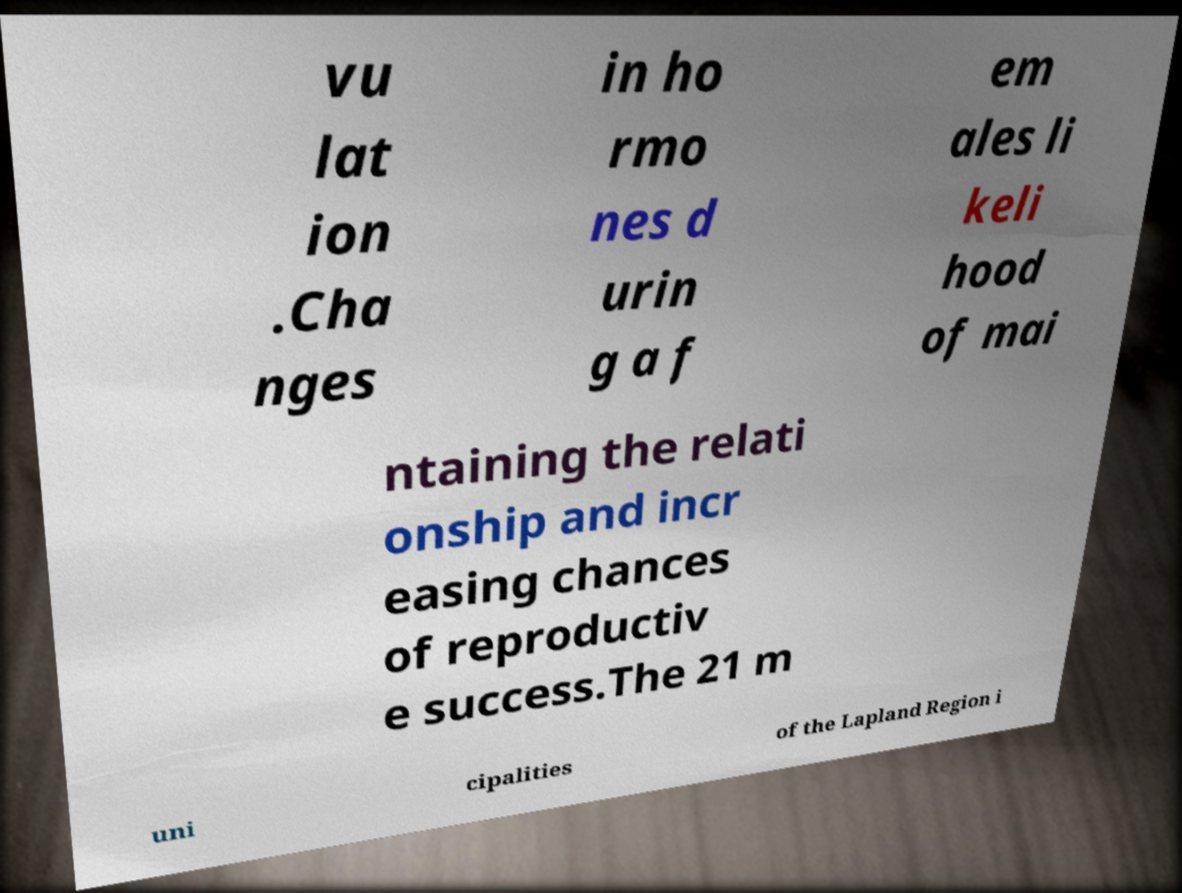Can you read and provide the text displayed in the image?This photo seems to have some interesting text. Can you extract and type it out for me? vu lat ion .Cha nges in ho rmo nes d urin g a f em ales li keli hood of mai ntaining the relati onship and incr easing chances of reproductiv e success.The 21 m uni cipalities of the Lapland Region i 